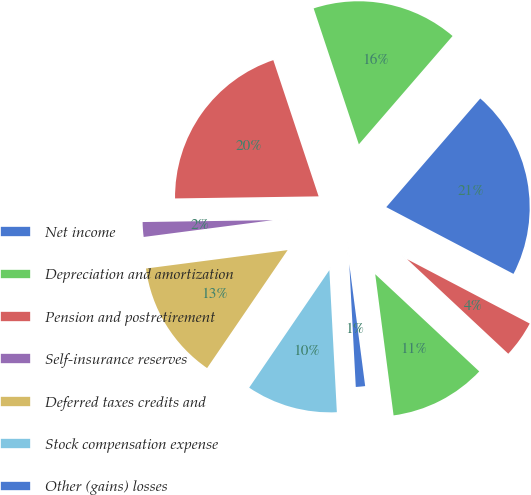Convert chart. <chart><loc_0><loc_0><loc_500><loc_500><pie_chart><fcel>Net income<fcel>Depreciation and amortization<fcel>Pension and postretirement<fcel>Self-insurance reserves<fcel>Deferred taxes credits and<fcel>Stock compensation expense<fcel>Other (gains) losses<fcel>Accounts receivable<fcel>Income taxes receivable<nl><fcel>21.34%<fcel>16.46%<fcel>20.12%<fcel>1.83%<fcel>13.41%<fcel>10.37%<fcel>1.22%<fcel>10.98%<fcel>4.27%<nl></chart> 